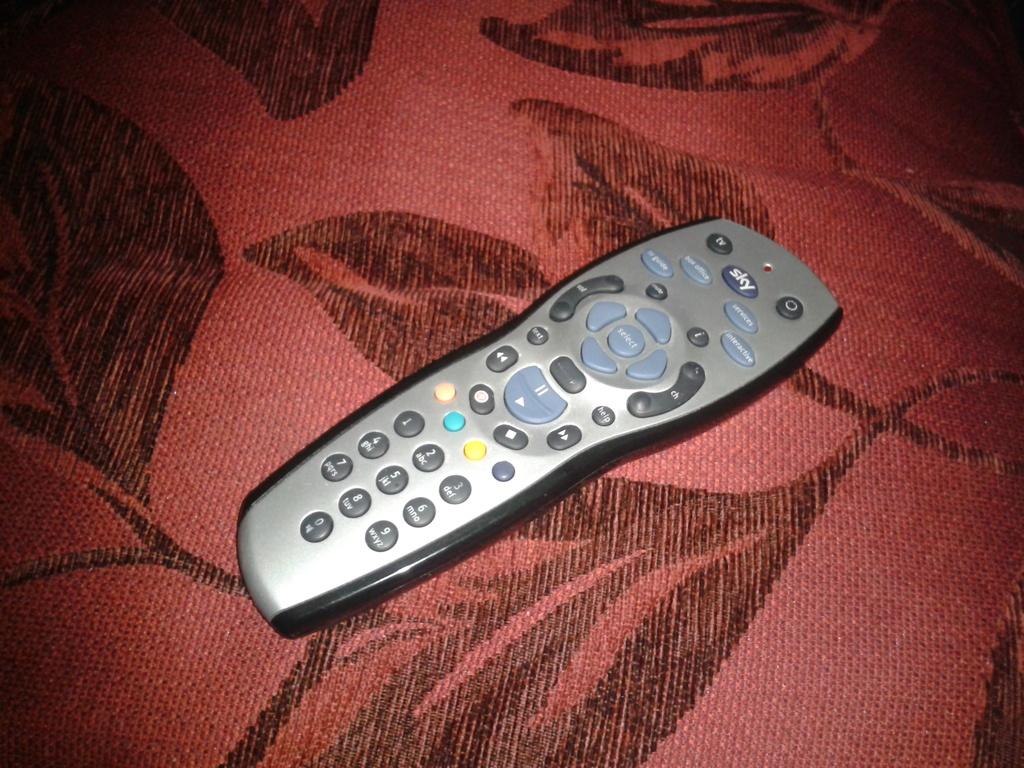What does the button just below the red dot at the top say?
Give a very brief answer. Sky. 